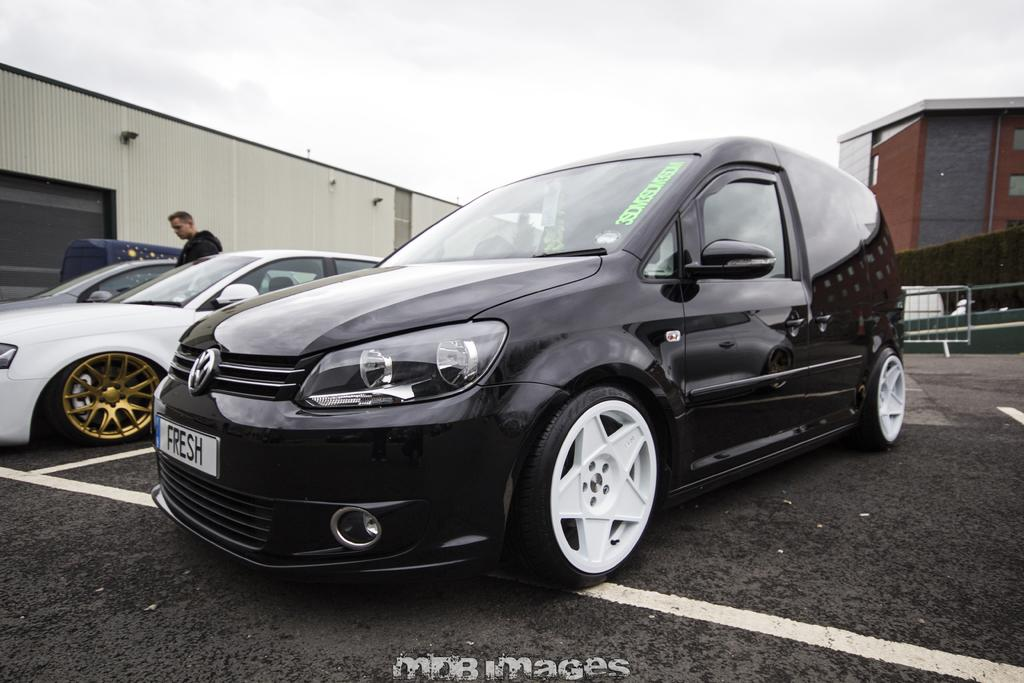What types of objects are present in the image? There are vehicles and a person in the image. What can be seen in the background of the image? There are buildings and plants in the background of the image. What is the condition of the sky in the image? The sky is cloudy in the image. What is the purpose of the fence in the image? The fence in the image serves as a barrier or boundary. What type of underwear is the person wearing in the image? There is no information about the person's underwear in the image, so it cannot be determined. What amusement park can be seen in the background of the image? There is no amusement park present in the image; it features buildings and plants in the background. 